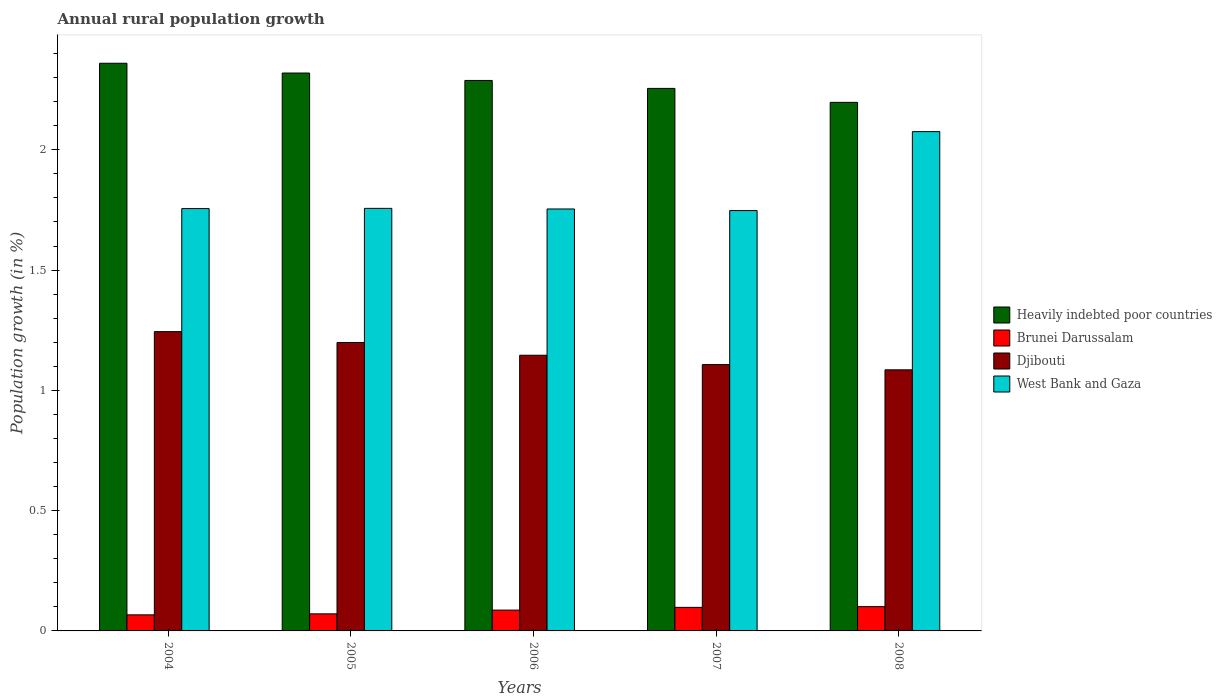Are the number of bars per tick equal to the number of legend labels?
Provide a succinct answer. Yes. How many bars are there on the 2nd tick from the right?
Ensure brevity in your answer.  4. What is the label of the 4th group of bars from the left?
Provide a short and direct response. 2007. What is the percentage of rural population growth in Heavily indebted poor countries in 2005?
Provide a succinct answer. 2.32. Across all years, what is the maximum percentage of rural population growth in West Bank and Gaza?
Give a very brief answer. 2.08. Across all years, what is the minimum percentage of rural population growth in Heavily indebted poor countries?
Give a very brief answer. 2.2. What is the total percentage of rural population growth in Brunei Darussalam in the graph?
Provide a short and direct response. 0.42. What is the difference between the percentage of rural population growth in Brunei Darussalam in 2004 and that in 2005?
Ensure brevity in your answer.  -0. What is the difference between the percentage of rural population growth in West Bank and Gaza in 2007 and the percentage of rural population growth in Brunei Darussalam in 2005?
Offer a very short reply. 1.68. What is the average percentage of rural population growth in Djibouti per year?
Ensure brevity in your answer.  1.16. In the year 2008, what is the difference between the percentage of rural population growth in Heavily indebted poor countries and percentage of rural population growth in Djibouti?
Give a very brief answer. 1.11. In how many years, is the percentage of rural population growth in Brunei Darussalam greater than 2.2 %?
Offer a very short reply. 0. What is the ratio of the percentage of rural population growth in Djibouti in 2005 to that in 2006?
Offer a very short reply. 1.05. What is the difference between the highest and the second highest percentage of rural population growth in West Bank and Gaza?
Give a very brief answer. 0.32. What is the difference between the highest and the lowest percentage of rural population growth in West Bank and Gaza?
Keep it short and to the point. 0.33. Is it the case that in every year, the sum of the percentage of rural population growth in Djibouti and percentage of rural population growth in Brunei Darussalam is greater than the sum of percentage of rural population growth in Heavily indebted poor countries and percentage of rural population growth in West Bank and Gaza?
Offer a terse response. No. What does the 3rd bar from the left in 2004 represents?
Ensure brevity in your answer.  Djibouti. What does the 3rd bar from the right in 2008 represents?
Provide a short and direct response. Brunei Darussalam. Is it the case that in every year, the sum of the percentage of rural population growth in Brunei Darussalam and percentage of rural population growth in West Bank and Gaza is greater than the percentage of rural population growth in Heavily indebted poor countries?
Your answer should be compact. No. Are all the bars in the graph horizontal?
Offer a very short reply. No. What is the difference between two consecutive major ticks on the Y-axis?
Ensure brevity in your answer.  0.5. Are the values on the major ticks of Y-axis written in scientific E-notation?
Make the answer very short. No. Does the graph contain any zero values?
Make the answer very short. No. Does the graph contain grids?
Ensure brevity in your answer.  No. Where does the legend appear in the graph?
Offer a terse response. Center right. How are the legend labels stacked?
Keep it short and to the point. Vertical. What is the title of the graph?
Your response must be concise. Annual rural population growth. What is the label or title of the X-axis?
Your answer should be compact. Years. What is the label or title of the Y-axis?
Your answer should be compact. Population growth (in %). What is the Population growth (in %) in Heavily indebted poor countries in 2004?
Keep it short and to the point. 2.36. What is the Population growth (in %) in Brunei Darussalam in 2004?
Your response must be concise. 0.07. What is the Population growth (in %) of Djibouti in 2004?
Your response must be concise. 1.24. What is the Population growth (in %) in West Bank and Gaza in 2004?
Your answer should be very brief. 1.76. What is the Population growth (in %) of Heavily indebted poor countries in 2005?
Your answer should be very brief. 2.32. What is the Population growth (in %) in Brunei Darussalam in 2005?
Provide a succinct answer. 0.07. What is the Population growth (in %) in Djibouti in 2005?
Offer a terse response. 1.2. What is the Population growth (in %) in West Bank and Gaza in 2005?
Your response must be concise. 1.76. What is the Population growth (in %) in Heavily indebted poor countries in 2006?
Offer a very short reply. 2.29. What is the Population growth (in %) of Brunei Darussalam in 2006?
Your response must be concise. 0.09. What is the Population growth (in %) of Djibouti in 2006?
Your answer should be compact. 1.15. What is the Population growth (in %) of West Bank and Gaza in 2006?
Provide a short and direct response. 1.75. What is the Population growth (in %) of Heavily indebted poor countries in 2007?
Keep it short and to the point. 2.26. What is the Population growth (in %) of Brunei Darussalam in 2007?
Keep it short and to the point. 0.1. What is the Population growth (in %) in Djibouti in 2007?
Ensure brevity in your answer.  1.11. What is the Population growth (in %) of West Bank and Gaza in 2007?
Your answer should be compact. 1.75. What is the Population growth (in %) in Heavily indebted poor countries in 2008?
Your response must be concise. 2.2. What is the Population growth (in %) in Brunei Darussalam in 2008?
Your answer should be very brief. 0.1. What is the Population growth (in %) of Djibouti in 2008?
Offer a terse response. 1.09. What is the Population growth (in %) of West Bank and Gaza in 2008?
Your response must be concise. 2.08. Across all years, what is the maximum Population growth (in %) in Heavily indebted poor countries?
Your answer should be compact. 2.36. Across all years, what is the maximum Population growth (in %) in Brunei Darussalam?
Your answer should be very brief. 0.1. Across all years, what is the maximum Population growth (in %) of Djibouti?
Ensure brevity in your answer.  1.24. Across all years, what is the maximum Population growth (in %) in West Bank and Gaza?
Your answer should be compact. 2.08. Across all years, what is the minimum Population growth (in %) in Heavily indebted poor countries?
Offer a terse response. 2.2. Across all years, what is the minimum Population growth (in %) in Brunei Darussalam?
Offer a terse response. 0.07. Across all years, what is the minimum Population growth (in %) of Djibouti?
Ensure brevity in your answer.  1.09. Across all years, what is the minimum Population growth (in %) in West Bank and Gaza?
Ensure brevity in your answer.  1.75. What is the total Population growth (in %) in Heavily indebted poor countries in the graph?
Offer a terse response. 11.42. What is the total Population growth (in %) in Brunei Darussalam in the graph?
Keep it short and to the point. 0.42. What is the total Population growth (in %) in Djibouti in the graph?
Ensure brevity in your answer.  5.78. What is the total Population growth (in %) of West Bank and Gaza in the graph?
Your answer should be compact. 9.09. What is the difference between the Population growth (in %) in Heavily indebted poor countries in 2004 and that in 2005?
Your response must be concise. 0.04. What is the difference between the Population growth (in %) of Brunei Darussalam in 2004 and that in 2005?
Ensure brevity in your answer.  -0. What is the difference between the Population growth (in %) of Djibouti in 2004 and that in 2005?
Offer a very short reply. 0.05. What is the difference between the Population growth (in %) of West Bank and Gaza in 2004 and that in 2005?
Provide a succinct answer. -0. What is the difference between the Population growth (in %) in Heavily indebted poor countries in 2004 and that in 2006?
Keep it short and to the point. 0.07. What is the difference between the Population growth (in %) of Brunei Darussalam in 2004 and that in 2006?
Offer a terse response. -0.02. What is the difference between the Population growth (in %) of Djibouti in 2004 and that in 2006?
Offer a terse response. 0.1. What is the difference between the Population growth (in %) of West Bank and Gaza in 2004 and that in 2006?
Ensure brevity in your answer.  0. What is the difference between the Population growth (in %) of Heavily indebted poor countries in 2004 and that in 2007?
Make the answer very short. 0.1. What is the difference between the Population growth (in %) of Brunei Darussalam in 2004 and that in 2007?
Provide a succinct answer. -0.03. What is the difference between the Population growth (in %) of Djibouti in 2004 and that in 2007?
Your answer should be very brief. 0.14. What is the difference between the Population growth (in %) in West Bank and Gaza in 2004 and that in 2007?
Give a very brief answer. 0.01. What is the difference between the Population growth (in %) of Heavily indebted poor countries in 2004 and that in 2008?
Provide a short and direct response. 0.16. What is the difference between the Population growth (in %) in Brunei Darussalam in 2004 and that in 2008?
Keep it short and to the point. -0.03. What is the difference between the Population growth (in %) in Djibouti in 2004 and that in 2008?
Your answer should be very brief. 0.16. What is the difference between the Population growth (in %) of West Bank and Gaza in 2004 and that in 2008?
Provide a short and direct response. -0.32. What is the difference between the Population growth (in %) in Heavily indebted poor countries in 2005 and that in 2006?
Make the answer very short. 0.03. What is the difference between the Population growth (in %) in Brunei Darussalam in 2005 and that in 2006?
Ensure brevity in your answer.  -0.02. What is the difference between the Population growth (in %) of Djibouti in 2005 and that in 2006?
Your response must be concise. 0.05. What is the difference between the Population growth (in %) of West Bank and Gaza in 2005 and that in 2006?
Provide a short and direct response. 0. What is the difference between the Population growth (in %) of Heavily indebted poor countries in 2005 and that in 2007?
Your answer should be very brief. 0.06. What is the difference between the Population growth (in %) of Brunei Darussalam in 2005 and that in 2007?
Make the answer very short. -0.03. What is the difference between the Population growth (in %) of Djibouti in 2005 and that in 2007?
Your answer should be compact. 0.09. What is the difference between the Population growth (in %) in West Bank and Gaza in 2005 and that in 2007?
Keep it short and to the point. 0.01. What is the difference between the Population growth (in %) of Heavily indebted poor countries in 2005 and that in 2008?
Ensure brevity in your answer.  0.12. What is the difference between the Population growth (in %) in Brunei Darussalam in 2005 and that in 2008?
Ensure brevity in your answer.  -0.03. What is the difference between the Population growth (in %) in Djibouti in 2005 and that in 2008?
Give a very brief answer. 0.11. What is the difference between the Population growth (in %) in West Bank and Gaza in 2005 and that in 2008?
Provide a succinct answer. -0.32. What is the difference between the Population growth (in %) of Heavily indebted poor countries in 2006 and that in 2007?
Ensure brevity in your answer.  0.03. What is the difference between the Population growth (in %) in Brunei Darussalam in 2006 and that in 2007?
Keep it short and to the point. -0.01. What is the difference between the Population growth (in %) of Djibouti in 2006 and that in 2007?
Your answer should be compact. 0.04. What is the difference between the Population growth (in %) of West Bank and Gaza in 2006 and that in 2007?
Your response must be concise. 0.01. What is the difference between the Population growth (in %) of Heavily indebted poor countries in 2006 and that in 2008?
Your answer should be very brief. 0.09. What is the difference between the Population growth (in %) in Brunei Darussalam in 2006 and that in 2008?
Make the answer very short. -0.01. What is the difference between the Population growth (in %) of Djibouti in 2006 and that in 2008?
Offer a very short reply. 0.06. What is the difference between the Population growth (in %) of West Bank and Gaza in 2006 and that in 2008?
Your answer should be very brief. -0.32. What is the difference between the Population growth (in %) of Heavily indebted poor countries in 2007 and that in 2008?
Your response must be concise. 0.06. What is the difference between the Population growth (in %) of Brunei Darussalam in 2007 and that in 2008?
Provide a short and direct response. -0. What is the difference between the Population growth (in %) in Djibouti in 2007 and that in 2008?
Your response must be concise. 0.02. What is the difference between the Population growth (in %) of West Bank and Gaza in 2007 and that in 2008?
Your answer should be very brief. -0.33. What is the difference between the Population growth (in %) of Heavily indebted poor countries in 2004 and the Population growth (in %) of Brunei Darussalam in 2005?
Ensure brevity in your answer.  2.29. What is the difference between the Population growth (in %) in Heavily indebted poor countries in 2004 and the Population growth (in %) in Djibouti in 2005?
Make the answer very short. 1.16. What is the difference between the Population growth (in %) of Heavily indebted poor countries in 2004 and the Population growth (in %) of West Bank and Gaza in 2005?
Keep it short and to the point. 0.6. What is the difference between the Population growth (in %) of Brunei Darussalam in 2004 and the Population growth (in %) of Djibouti in 2005?
Offer a terse response. -1.13. What is the difference between the Population growth (in %) of Brunei Darussalam in 2004 and the Population growth (in %) of West Bank and Gaza in 2005?
Ensure brevity in your answer.  -1.69. What is the difference between the Population growth (in %) in Djibouti in 2004 and the Population growth (in %) in West Bank and Gaza in 2005?
Your response must be concise. -0.51. What is the difference between the Population growth (in %) in Heavily indebted poor countries in 2004 and the Population growth (in %) in Brunei Darussalam in 2006?
Make the answer very short. 2.27. What is the difference between the Population growth (in %) of Heavily indebted poor countries in 2004 and the Population growth (in %) of Djibouti in 2006?
Your answer should be compact. 1.21. What is the difference between the Population growth (in %) of Heavily indebted poor countries in 2004 and the Population growth (in %) of West Bank and Gaza in 2006?
Your response must be concise. 0.61. What is the difference between the Population growth (in %) of Brunei Darussalam in 2004 and the Population growth (in %) of Djibouti in 2006?
Offer a terse response. -1.08. What is the difference between the Population growth (in %) of Brunei Darussalam in 2004 and the Population growth (in %) of West Bank and Gaza in 2006?
Your answer should be compact. -1.69. What is the difference between the Population growth (in %) in Djibouti in 2004 and the Population growth (in %) in West Bank and Gaza in 2006?
Ensure brevity in your answer.  -0.51. What is the difference between the Population growth (in %) of Heavily indebted poor countries in 2004 and the Population growth (in %) of Brunei Darussalam in 2007?
Keep it short and to the point. 2.26. What is the difference between the Population growth (in %) of Heavily indebted poor countries in 2004 and the Population growth (in %) of Djibouti in 2007?
Offer a terse response. 1.25. What is the difference between the Population growth (in %) in Heavily indebted poor countries in 2004 and the Population growth (in %) in West Bank and Gaza in 2007?
Make the answer very short. 0.61. What is the difference between the Population growth (in %) of Brunei Darussalam in 2004 and the Population growth (in %) of Djibouti in 2007?
Make the answer very short. -1.04. What is the difference between the Population growth (in %) in Brunei Darussalam in 2004 and the Population growth (in %) in West Bank and Gaza in 2007?
Make the answer very short. -1.68. What is the difference between the Population growth (in %) in Djibouti in 2004 and the Population growth (in %) in West Bank and Gaza in 2007?
Your answer should be very brief. -0.5. What is the difference between the Population growth (in %) of Heavily indebted poor countries in 2004 and the Population growth (in %) of Brunei Darussalam in 2008?
Provide a short and direct response. 2.26. What is the difference between the Population growth (in %) in Heavily indebted poor countries in 2004 and the Population growth (in %) in Djibouti in 2008?
Make the answer very short. 1.27. What is the difference between the Population growth (in %) in Heavily indebted poor countries in 2004 and the Population growth (in %) in West Bank and Gaza in 2008?
Make the answer very short. 0.28. What is the difference between the Population growth (in %) of Brunei Darussalam in 2004 and the Population growth (in %) of Djibouti in 2008?
Make the answer very short. -1.02. What is the difference between the Population growth (in %) of Brunei Darussalam in 2004 and the Population growth (in %) of West Bank and Gaza in 2008?
Offer a very short reply. -2.01. What is the difference between the Population growth (in %) in Djibouti in 2004 and the Population growth (in %) in West Bank and Gaza in 2008?
Offer a terse response. -0.83. What is the difference between the Population growth (in %) of Heavily indebted poor countries in 2005 and the Population growth (in %) of Brunei Darussalam in 2006?
Your answer should be compact. 2.23. What is the difference between the Population growth (in %) of Heavily indebted poor countries in 2005 and the Population growth (in %) of Djibouti in 2006?
Provide a short and direct response. 1.17. What is the difference between the Population growth (in %) of Heavily indebted poor countries in 2005 and the Population growth (in %) of West Bank and Gaza in 2006?
Ensure brevity in your answer.  0.57. What is the difference between the Population growth (in %) in Brunei Darussalam in 2005 and the Population growth (in %) in Djibouti in 2006?
Keep it short and to the point. -1.08. What is the difference between the Population growth (in %) in Brunei Darussalam in 2005 and the Population growth (in %) in West Bank and Gaza in 2006?
Your response must be concise. -1.68. What is the difference between the Population growth (in %) of Djibouti in 2005 and the Population growth (in %) of West Bank and Gaza in 2006?
Provide a short and direct response. -0.56. What is the difference between the Population growth (in %) in Heavily indebted poor countries in 2005 and the Population growth (in %) in Brunei Darussalam in 2007?
Provide a short and direct response. 2.22. What is the difference between the Population growth (in %) of Heavily indebted poor countries in 2005 and the Population growth (in %) of Djibouti in 2007?
Keep it short and to the point. 1.21. What is the difference between the Population growth (in %) in Heavily indebted poor countries in 2005 and the Population growth (in %) in West Bank and Gaza in 2007?
Offer a terse response. 0.57. What is the difference between the Population growth (in %) of Brunei Darussalam in 2005 and the Population growth (in %) of Djibouti in 2007?
Provide a short and direct response. -1.04. What is the difference between the Population growth (in %) of Brunei Darussalam in 2005 and the Population growth (in %) of West Bank and Gaza in 2007?
Offer a very short reply. -1.68. What is the difference between the Population growth (in %) in Djibouti in 2005 and the Population growth (in %) in West Bank and Gaza in 2007?
Make the answer very short. -0.55. What is the difference between the Population growth (in %) of Heavily indebted poor countries in 2005 and the Population growth (in %) of Brunei Darussalam in 2008?
Provide a short and direct response. 2.22. What is the difference between the Population growth (in %) in Heavily indebted poor countries in 2005 and the Population growth (in %) in Djibouti in 2008?
Make the answer very short. 1.23. What is the difference between the Population growth (in %) of Heavily indebted poor countries in 2005 and the Population growth (in %) of West Bank and Gaza in 2008?
Provide a short and direct response. 0.24. What is the difference between the Population growth (in %) of Brunei Darussalam in 2005 and the Population growth (in %) of Djibouti in 2008?
Provide a succinct answer. -1.01. What is the difference between the Population growth (in %) of Brunei Darussalam in 2005 and the Population growth (in %) of West Bank and Gaza in 2008?
Offer a very short reply. -2. What is the difference between the Population growth (in %) of Djibouti in 2005 and the Population growth (in %) of West Bank and Gaza in 2008?
Your answer should be compact. -0.88. What is the difference between the Population growth (in %) in Heavily indebted poor countries in 2006 and the Population growth (in %) in Brunei Darussalam in 2007?
Offer a terse response. 2.19. What is the difference between the Population growth (in %) in Heavily indebted poor countries in 2006 and the Population growth (in %) in Djibouti in 2007?
Ensure brevity in your answer.  1.18. What is the difference between the Population growth (in %) of Heavily indebted poor countries in 2006 and the Population growth (in %) of West Bank and Gaza in 2007?
Make the answer very short. 0.54. What is the difference between the Population growth (in %) in Brunei Darussalam in 2006 and the Population growth (in %) in Djibouti in 2007?
Your answer should be compact. -1.02. What is the difference between the Population growth (in %) of Brunei Darussalam in 2006 and the Population growth (in %) of West Bank and Gaza in 2007?
Offer a terse response. -1.66. What is the difference between the Population growth (in %) of Djibouti in 2006 and the Population growth (in %) of West Bank and Gaza in 2007?
Ensure brevity in your answer.  -0.6. What is the difference between the Population growth (in %) of Heavily indebted poor countries in 2006 and the Population growth (in %) of Brunei Darussalam in 2008?
Provide a short and direct response. 2.19. What is the difference between the Population growth (in %) in Heavily indebted poor countries in 2006 and the Population growth (in %) in Djibouti in 2008?
Offer a very short reply. 1.2. What is the difference between the Population growth (in %) in Heavily indebted poor countries in 2006 and the Population growth (in %) in West Bank and Gaza in 2008?
Your answer should be very brief. 0.21. What is the difference between the Population growth (in %) in Brunei Darussalam in 2006 and the Population growth (in %) in Djibouti in 2008?
Provide a short and direct response. -1. What is the difference between the Population growth (in %) in Brunei Darussalam in 2006 and the Population growth (in %) in West Bank and Gaza in 2008?
Give a very brief answer. -1.99. What is the difference between the Population growth (in %) in Djibouti in 2006 and the Population growth (in %) in West Bank and Gaza in 2008?
Offer a terse response. -0.93. What is the difference between the Population growth (in %) of Heavily indebted poor countries in 2007 and the Population growth (in %) of Brunei Darussalam in 2008?
Keep it short and to the point. 2.15. What is the difference between the Population growth (in %) of Heavily indebted poor countries in 2007 and the Population growth (in %) of Djibouti in 2008?
Your response must be concise. 1.17. What is the difference between the Population growth (in %) in Heavily indebted poor countries in 2007 and the Population growth (in %) in West Bank and Gaza in 2008?
Provide a succinct answer. 0.18. What is the difference between the Population growth (in %) of Brunei Darussalam in 2007 and the Population growth (in %) of Djibouti in 2008?
Your answer should be compact. -0.99. What is the difference between the Population growth (in %) in Brunei Darussalam in 2007 and the Population growth (in %) in West Bank and Gaza in 2008?
Your response must be concise. -1.98. What is the difference between the Population growth (in %) of Djibouti in 2007 and the Population growth (in %) of West Bank and Gaza in 2008?
Ensure brevity in your answer.  -0.97. What is the average Population growth (in %) in Heavily indebted poor countries per year?
Provide a short and direct response. 2.28. What is the average Population growth (in %) in Brunei Darussalam per year?
Offer a terse response. 0.08. What is the average Population growth (in %) of Djibouti per year?
Your response must be concise. 1.16. What is the average Population growth (in %) of West Bank and Gaza per year?
Ensure brevity in your answer.  1.82. In the year 2004, what is the difference between the Population growth (in %) of Heavily indebted poor countries and Population growth (in %) of Brunei Darussalam?
Your response must be concise. 2.29. In the year 2004, what is the difference between the Population growth (in %) in Heavily indebted poor countries and Population growth (in %) in Djibouti?
Offer a very short reply. 1.12. In the year 2004, what is the difference between the Population growth (in %) in Heavily indebted poor countries and Population growth (in %) in West Bank and Gaza?
Your answer should be compact. 0.6. In the year 2004, what is the difference between the Population growth (in %) of Brunei Darussalam and Population growth (in %) of Djibouti?
Give a very brief answer. -1.18. In the year 2004, what is the difference between the Population growth (in %) of Brunei Darussalam and Population growth (in %) of West Bank and Gaza?
Your answer should be very brief. -1.69. In the year 2004, what is the difference between the Population growth (in %) in Djibouti and Population growth (in %) in West Bank and Gaza?
Provide a short and direct response. -0.51. In the year 2005, what is the difference between the Population growth (in %) in Heavily indebted poor countries and Population growth (in %) in Brunei Darussalam?
Your answer should be compact. 2.25. In the year 2005, what is the difference between the Population growth (in %) in Heavily indebted poor countries and Population growth (in %) in Djibouti?
Ensure brevity in your answer.  1.12. In the year 2005, what is the difference between the Population growth (in %) in Heavily indebted poor countries and Population growth (in %) in West Bank and Gaza?
Make the answer very short. 0.56. In the year 2005, what is the difference between the Population growth (in %) of Brunei Darussalam and Population growth (in %) of Djibouti?
Give a very brief answer. -1.13. In the year 2005, what is the difference between the Population growth (in %) of Brunei Darussalam and Population growth (in %) of West Bank and Gaza?
Your answer should be very brief. -1.69. In the year 2005, what is the difference between the Population growth (in %) of Djibouti and Population growth (in %) of West Bank and Gaza?
Your response must be concise. -0.56. In the year 2006, what is the difference between the Population growth (in %) of Heavily indebted poor countries and Population growth (in %) of Brunei Darussalam?
Ensure brevity in your answer.  2.2. In the year 2006, what is the difference between the Population growth (in %) in Heavily indebted poor countries and Population growth (in %) in Djibouti?
Your response must be concise. 1.14. In the year 2006, what is the difference between the Population growth (in %) of Heavily indebted poor countries and Population growth (in %) of West Bank and Gaza?
Ensure brevity in your answer.  0.53. In the year 2006, what is the difference between the Population growth (in %) of Brunei Darussalam and Population growth (in %) of Djibouti?
Offer a terse response. -1.06. In the year 2006, what is the difference between the Population growth (in %) in Brunei Darussalam and Population growth (in %) in West Bank and Gaza?
Ensure brevity in your answer.  -1.67. In the year 2006, what is the difference between the Population growth (in %) in Djibouti and Population growth (in %) in West Bank and Gaza?
Offer a very short reply. -0.61. In the year 2007, what is the difference between the Population growth (in %) in Heavily indebted poor countries and Population growth (in %) in Brunei Darussalam?
Offer a terse response. 2.16. In the year 2007, what is the difference between the Population growth (in %) in Heavily indebted poor countries and Population growth (in %) in Djibouti?
Give a very brief answer. 1.15. In the year 2007, what is the difference between the Population growth (in %) in Heavily indebted poor countries and Population growth (in %) in West Bank and Gaza?
Offer a very short reply. 0.51. In the year 2007, what is the difference between the Population growth (in %) in Brunei Darussalam and Population growth (in %) in Djibouti?
Provide a succinct answer. -1.01. In the year 2007, what is the difference between the Population growth (in %) in Brunei Darussalam and Population growth (in %) in West Bank and Gaza?
Offer a very short reply. -1.65. In the year 2007, what is the difference between the Population growth (in %) of Djibouti and Population growth (in %) of West Bank and Gaza?
Offer a very short reply. -0.64. In the year 2008, what is the difference between the Population growth (in %) in Heavily indebted poor countries and Population growth (in %) in Brunei Darussalam?
Your answer should be compact. 2.1. In the year 2008, what is the difference between the Population growth (in %) of Heavily indebted poor countries and Population growth (in %) of Djibouti?
Offer a very short reply. 1.11. In the year 2008, what is the difference between the Population growth (in %) in Heavily indebted poor countries and Population growth (in %) in West Bank and Gaza?
Your answer should be compact. 0.12. In the year 2008, what is the difference between the Population growth (in %) of Brunei Darussalam and Population growth (in %) of Djibouti?
Your answer should be compact. -0.98. In the year 2008, what is the difference between the Population growth (in %) in Brunei Darussalam and Population growth (in %) in West Bank and Gaza?
Offer a very short reply. -1.97. In the year 2008, what is the difference between the Population growth (in %) in Djibouti and Population growth (in %) in West Bank and Gaza?
Keep it short and to the point. -0.99. What is the ratio of the Population growth (in %) of Heavily indebted poor countries in 2004 to that in 2005?
Make the answer very short. 1.02. What is the ratio of the Population growth (in %) of Brunei Darussalam in 2004 to that in 2005?
Your answer should be compact. 0.94. What is the ratio of the Population growth (in %) in Djibouti in 2004 to that in 2005?
Provide a succinct answer. 1.04. What is the ratio of the Population growth (in %) of West Bank and Gaza in 2004 to that in 2005?
Your answer should be very brief. 1. What is the ratio of the Population growth (in %) of Heavily indebted poor countries in 2004 to that in 2006?
Offer a terse response. 1.03. What is the ratio of the Population growth (in %) of Brunei Darussalam in 2004 to that in 2006?
Your answer should be very brief. 0.77. What is the ratio of the Population growth (in %) of Djibouti in 2004 to that in 2006?
Give a very brief answer. 1.09. What is the ratio of the Population growth (in %) in West Bank and Gaza in 2004 to that in 2006?
Provide a succinct answer. 1. What is the ratio of the Population growth (in %) of Heavily indebted poor countries in 2004 to that in 2007?
Ensure brevity in your answer.  1.05. What is the ratio of the Population growth (in %) in Brunei Darussalam in 2004 to that in 2007?
Provide a succinct answer. 0.68. What is the ratio of the Population growth (in %) in Djibouti in 2004 to that in 2007?
Give a very brief answer. 1.12. What is the ratio of the Population growth (in %) in West Bank and Gaza in 2004 to that in 2007?
Provide a short and direct response. 1. What is the ratio of the Population growth (in %) in Heavily indebted poor countries in 2004 to that in 2008?
Give a very brief answer. 1.07. What is the ratio of the Population growth (in %) of Brunei Darussalam in 2004 to that in 2008?
Your answer should be very brief. 0.66. What is the ratio of the Population growth (in %) in Djibouti in 2004 to that in 2008?
Your answer should be very brief. 1.15. What is the ratio of the Population growth (in %) of West Bank and Gaza in 2004 to that in 2008?
Your response must be concise. 0.85. What is the ratio of the Population growth (in %) of Heavily indebted poor countries in 2005 to that in 2006?
Offer a very short reply. 1.01. What is the ratio of the Population growth (in %) in Brunei Darussalam in 2005 to that in 2006?
Your response must be concise. 0.82. What is the ratio of the Population growth (in %) of Djibouti in 2005 to that in 2006?
Keep it short and to the point. 1.05. What is the ratio of the Population growth (in %) in Heavily indebted poor countries in 2005 to that in 2007?
Ensure brevity in your answer.  1.03. What is the ratio of the Population growth (in %) in Brunei Darussalam in 2005 to that in 2007?
Your answer should be compact. 0.72. What is the ratio of the Population growth (in %) in Djibouti in 2005 to that in 2007?
Your answer should be very brief. 1.08. What is the ratio of the Population growth (in %) of Heavily indebted poor countries in 2005 to that in 2008?
Your answer should be compact. 1.06. What is the ratio of the Population growth (in %) of Brunei Darussalam in 2005 to that in 2008?
Provide a short and direct response. 0.7. What is the ratio of the Population growth (in %) in Djibouti in 2005 to that in 2008?
Offer a very short reply. 1.1. What is the ratio of the Population growth (in %) of West Bank and Gaza in 2005 to that in 2008?
Provide a short and direct response. 0.85. What is the ratio of the Population growth (in %) of Heavily indebted poor countries in 2006 to that in 2007?
Give a very brief answer. 1.01. What is the ratio of the Population growth (in %) of Brunei Darussalam in 2006 to that in 2007?
Keep it short and to the point. 0.88. What is the ratio of the Population growth (in %) in Djibouti in 2006 to that in 2007?
Provide a succinct answer. 1.04. What is the ratio of the Population growth (in %) in West Bank and Gaza in 2006 to that in 2007?
Ensure brevity in your answer.  1. What is the ratio of the Population growth (in %) in Heavily indebted poor countries in 2006 to that in 2008?
Your answer should be very brief. 1.04. What is the ratio of the Population growth (in %) in Brunei Darussalam in 2006 to that in 2008?
Ensure brevity in your answer.  0.86. What is the ratio of the Population growth (in %) in Djibouti in 2006 to that in 2008?
Your response must be concise. 1.06. What is the ratio of the Population growth (in %) in West Bank and Gaza in 2006 to that in 2008?
Give a very brief answer. 0.85. What is the ratio of the Population growth (in %) in Heavily indebted poor countries in 2007 to that in 2008?
Give a very brief answer. 1.03. What is the ratio of the Population growth (in %) in Brunei Darussalam in 2007 to that in 2008?
Provide a short and direct response. 0.97. What is the ratio of the Population growth (in %) in Djibouti in 2007 to that in 2008?
Give a very brief answer. 1.02. What is the ratio of the Population growth (in %) of West Bank and Gaza in 2007 to that in 2008?
Offer a terse response. 0.84. What is the difference between the highest and the second highest Population growth (in %) of Heavily indebted poor countries?
Keep it short and to the point. 0.04. What is the difference between the highest and the second highest Population growth (in %) in Brunei Darussalam?
Give a very brief answer. 0. What is the difference between the highest and the second highest Population growth (in %) of Djibouti?
Make the answer very short. 0.05. What is the difference between the highest and the second highest Population growth (in %) in West Bank and Gaza?
Your response must be concise. 0.32. What is the difference between the highest and the lowest Population growth (in %) of Heavily indebted poor countries?
Offer a very short reply. 0.16. What is the difference between the highest and the lowest Population growth (in %) of Brunei Darussalam?
Keep it short and to the point. 0.03. What is the difference between the highest and the lowest Population growth (in %) of Djibouti?
Your response must be concise. 0.16. What is the difference between the highest and the lowest Population growth (in %) of West Bank and Gaza?
Your answer should be compact. 0.33. 